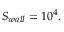<formula> <loc_0><loc_0><loc_500><loc_500>S _ { w a l l } = 1 0 ^ { 4 } .</formula> 